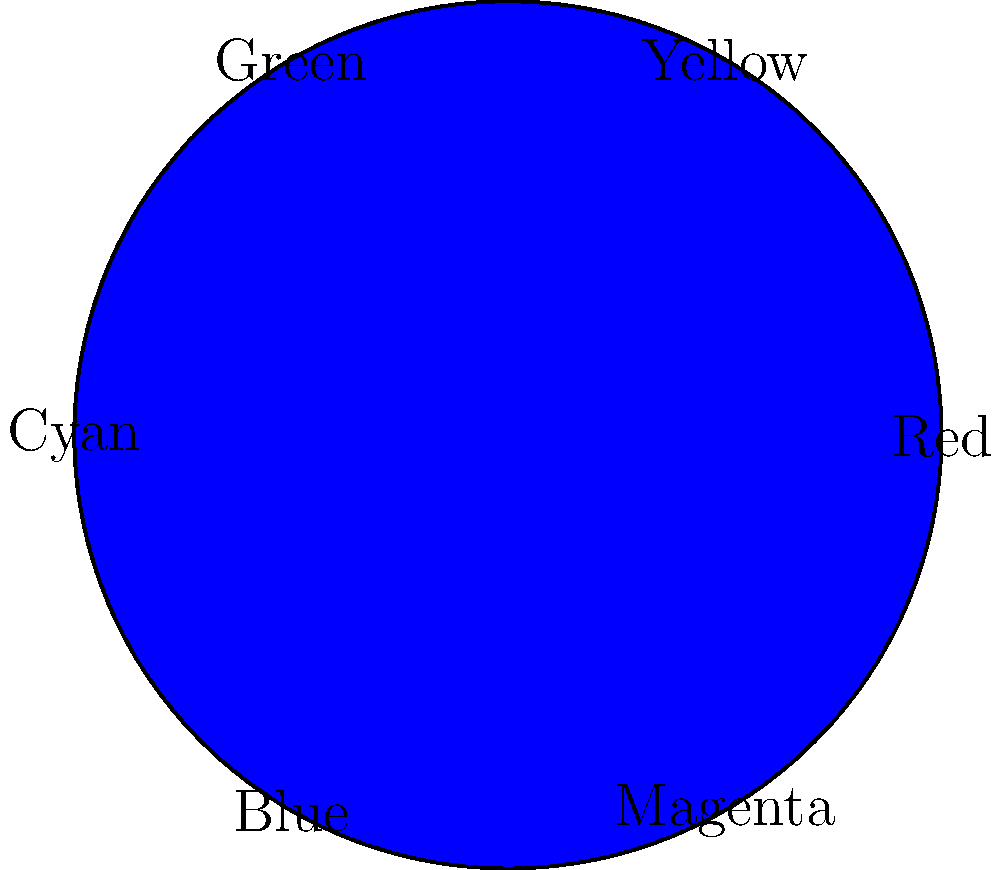As a freelance graphic designer, you're working on a garden-themed project. Using the color wheel provided, which color would you choose to create the most vibrant contrast with a predominantly green design? To determine the most vibrant contrast for a predominantly green design, we need to follow these steps:

1. Locate green on the color wheel (it's at the top-left of the wheel).
2. Identify the color directly opposite green on the wheel. This is known as the complementary color.
3. The color opposite green is red (bottom of the wheel).

Complementary colors create the most vibrant contrast when used together. This is because:

a) They are at opposite ends of the color spectrum.
b) They stimulate different types of cone cells in the human eye simultaneously.
c) When placed side by side, they appear to intensify each other.

In color theory, this high contrast between complementary colors is often used to create visual interest and draw attention to specific elements in a design.

For a garden-themed project, using red accents against a predominantly green background could effectively highlight certain elements, mimicking the natural contrast found in some flowers and their foliage.
Answer: Red 